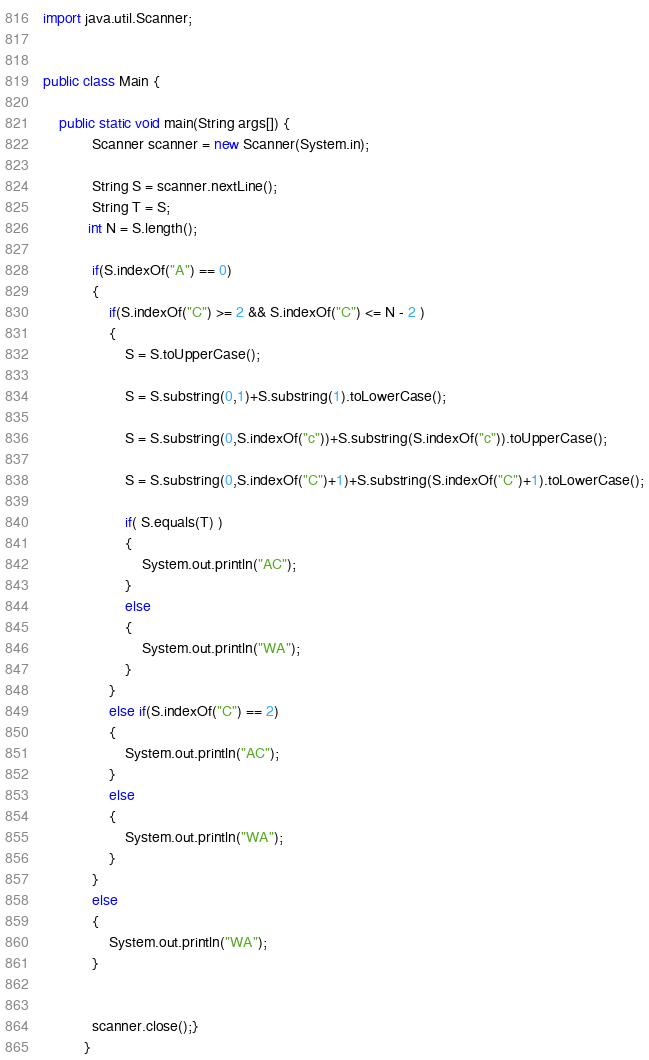Convert code to text. <code><loc_0><loc_0><loc_500><loc_500><_Java_>import java.util.Scanner;


public class Main {
	  
	public static void main(String args[]) {
		    Scanner scanner = new Scanner(System.in);
		    
		    String S = scanner.nextLine();
		    String T = S;
		   int N = S.length();

		    if(S.indexOf("A") == 0) 
		    {
		    	if(S.indexOf("C") >= 2 && S.indexOf("C") <= N - 2 ) 
		    	{
		    		S = S.toUpperCase();
		    	
		    		S = S.substring(0,1)+S.substring(1).toLowerCase();
		    		
		    		S = S.substring(0,S.indexOf("c"))+S.substring(S.indexOf("c")).toUpperCase();
		    		
		    		S = S.substring(0,S.indexOf("C")+1)+S.substring(S.indexOf("C")+1).toLowerCase();
		  
		    		if( S.equals(T) ) 
		    		{
		    			System.out.println("AC");
		    		}
		    		else 
		    		{
		    			System.out.println("WA");
		    		}
		    	}
		    	else if(S.indexOf("C") == 2)
		    	{
		    		System.out.println("AC");
		    	}
		    	else 
		    	{
		    		System.out.println("WA");
		    	}
		    }
		    else 
		    {
		    	System.out.println("WA");
		    }
		    
		    
		    scanner.close();}
		  }</code> 